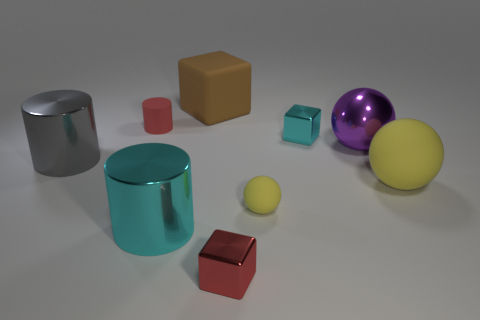Can you tell me about the color scheme of the objects in the image? The image features a muted color scheme with objects in primary and secondary colors, including red, yellow, and blue, as well as the silver of metal and the purple-pink gradient of the reflective sphere. These colors provide a contrast against the neutral background, making them stand out and enhancing the overall visual appeal. Do these colors have any significance? While the colors in the image do not seem to have a thematic significance, their selection and placement could be guided by principles of color theory. They provide visual balance and contrast, which could evoke different emotions and moods in viewers, depending on their cultural and individual associations with these colors. 